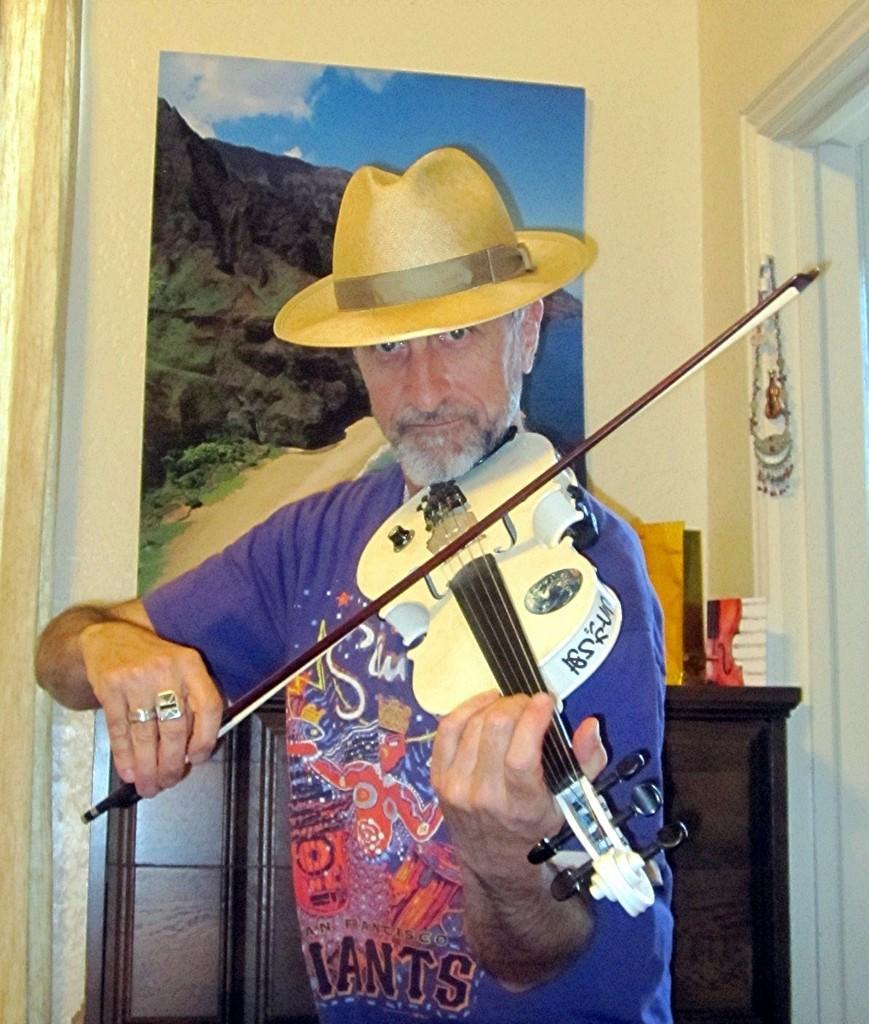How would you summarize this image in a sentence or two? In this picture we have a man standing and playing a violin and in the back ground we have a frame attached to a wall and a table. 